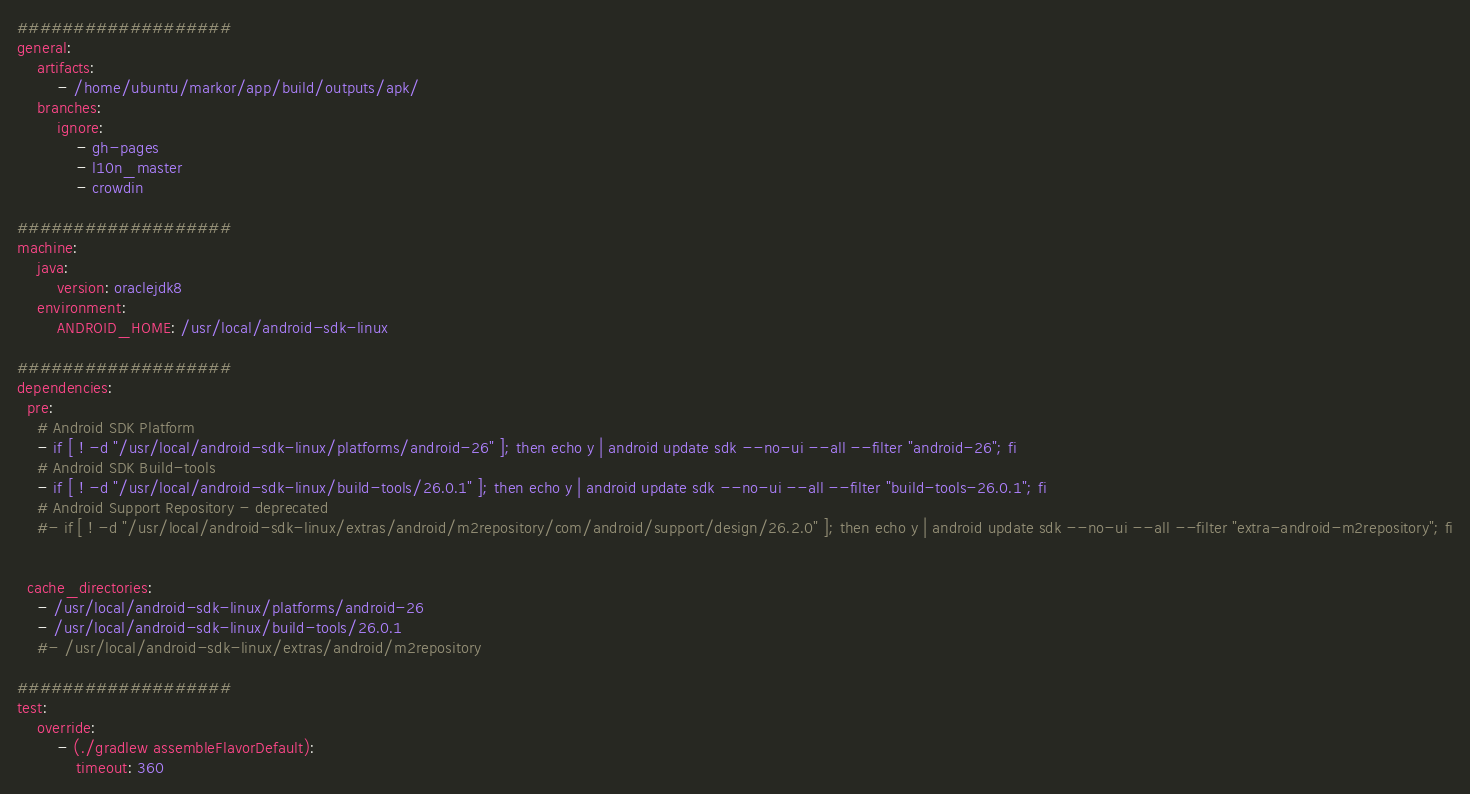Convert code to text. <code><loc_0><loc_0><loc_500><loc_500><_YAML_>###################
general:
    artifacts:
        - /home/ubuntu/markor/app/build/outputs/apk/
    branches:
        ignore:
            - gh-pages
            - l10n_master
            - crowdin

###################
machine:
    java:
        version: oraclejdk8
    environment:
        ANDROID_HOME: /usr/local/android-sdk-linux

###################
dependencies:
  pre:
    # Android SDK Platform
    - if [ ! -d "/usr/local/android-sdk-linux/platforms/android-26" ]; then echo y | android update sdk --no-ui --all --filter "android-26"; fi
    # Android SDK Build-tools
    - if [ ! -d "/usr/local/android-sdk-linux/build-tools/26.0.1" ]; then echo y | android update sdk --no-ui --all --filter "build-tools-26.0.1"; fi
    # Android Support Repository - deprecated
    #- if [ ! -d "/usr/local/android-sdk-linux/extras/android/m2repository/com/android/support/design/26.2.0" ]; then echo y | android update sdk --no-ui --all --filter "extra-android-m2repository"; fi
    

  cache_directories:
    - /usr/local/android-sdk-linux/platforms/android-26
    - /usr/local/android-sdk-linux/build-tools/26.0.1
    #- /usr/local/android-sdk-linux/extras/android/m2repository

###################
test:
    override:
        - (./gradlew assembleFlavorDefault):
            timeout: 360
</code> 